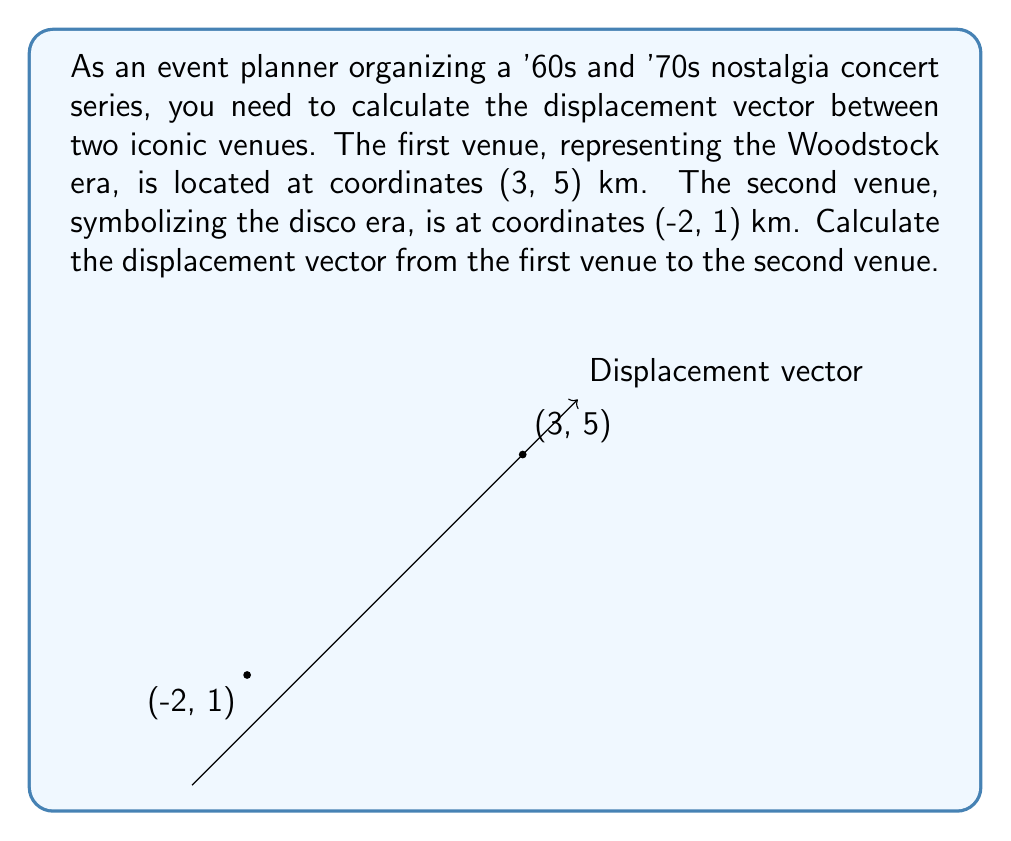Solve this math problem. To calculate the displacement vector, we need to subtract the initial position vector from the final position vector.

Let's define our vectors:
1. Initial position (Woodstock era venue): $\vec{r}_1 = (3, 5)$
2. Final position (Disco era venue): $\vec{r}_2 = (-2, 1)$

The displacement vector $\vec{d}$ is given by:

$$\vec{d} = \vec{r}_2 - \vec{r}_1$$

Subtracting the vectors component-wise:

$$\begin{align}
\vec{d} &= (-2, 1) - (3, 5) \\
&= (-2 - 3, 1 - 5) \\
&= (-5, -4)
\end{align}$$

Therefore, the displacement vector from the Woodstock era venue to the Disco era venue is $(-5, -4)$ km.

To interpret this result:
- The negative x-component (-5) means the second venue is 5 km west of the first venue.
- The negative y-component (-4) means the second venue is 4 km south of the first venue.
Answer: $(-5, -4)$ km 